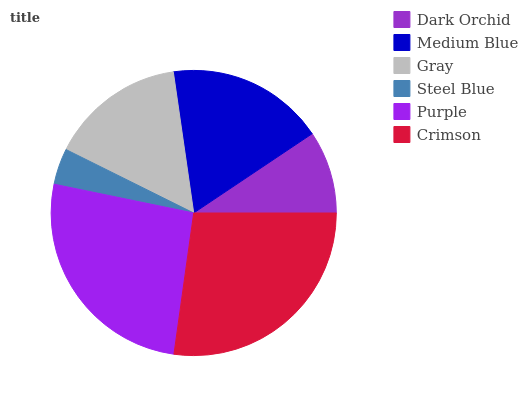Is Steel Blue the minimum?
Answer yes or no. Yes. Is Crimson the maximum?
Answer yes or no. Yes. Is Medium Blue the minimum?
Answer yes or no. No. Is Medium Blue the maximum?
Answer yes or no. No. Is Medium Blue greater than Dark Orchid?
Answer yes or no. Yes. Is Dark Orchid less than Medium Blue?
Answer yes or no. Yes. Is Dark Orchid greater than Medium Blue?
Answer yes or no. No. Is Medium Blue less than Dark Orchid?
Answer yes or no. No. Is Medium Blue the high median?
Answer yes or no. Yes. Is Gray the low median?
Answer yes or no. Yes. Is Gray the high median?
Answer yes or no. No. Is Purple the low median?
Answer yes or no. No. 